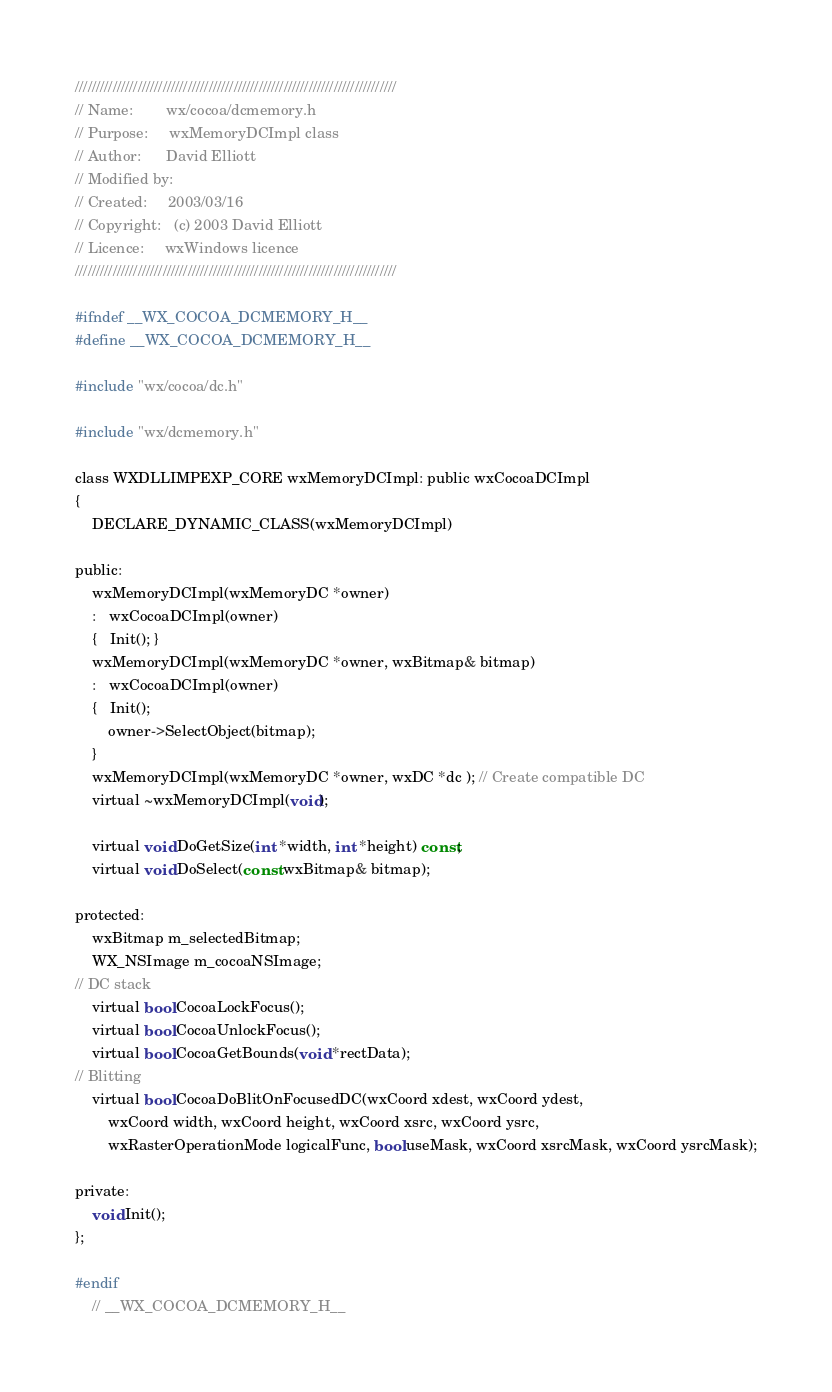Convert code to text. <code><loc_0><loc_0><loc_500><loc_500><_C_>/////////////////////////////////////////////////////////////////////////////
// Name:        wx/cocoa/dcmemory.h
// Purpose:     wxMemoryDCImpl class
// Author:      David Elliott
// Modified by:
// Created:     2003/03/16
// Copyright:   (c) 2003 David Elliott
// Licence:     wxWindows licence
/////////////////////////////////////////////////////////////////////////////

#ifndef __WX_COCOA_DCMEMORY_H__
#define __WX_COCOA_DCMEMORY_H__

#include "wx/cocoa/dc.h"

#include "wx/dcmemory.h"

class WXDLLIMPEXP_CORE wxMemoryDCImpl: public wxCocoaDCImpl
{
    DECLARE_DYNAMIC_CLASS(wxMemoryDCImpl)

public:
    wxMemoryDCImpl(wxMemoryDC *owner)
    :   wxCocoaDCImpl(owner)
    {   Init(); }
    wxMemoryDCImpl(wxMemoryDC *owner, wxBitmap& bitmap)
    :   wxCocoaDCImpl(owner)
    {   Init();
        owner->SelectObject(bitmap);
    }
    wxMemoryDCImpl(wxMemoryDC *owner, wxDC *dc ); // Create compatible DC
    virtual ~wxMemoryDCImpl(void);

    virtual void DoGetSize(int *width, int *height) const;
    virtual void DoSelect(const wxBitmap& bitmap);

protected:
    wxBitmap m_selectedBitmap;
    WX_NSImage m_cocoaNSImage;
// DC stack
    virtual bool CocoaLockFocus();
    virtual bool CocoaUnlockFocus();
    virtual bool CocoaGetBounds(void *rectData);
// Blitting
    virtual bool CocoaDoBlitOnFocusedDC(wxCoord xdest, wxCoord ydest,
        wxCoord width, wxCoord height, wxCoord xsrc, wxCoord ysrc,
        wxRasterOperationMode logicalFunc, bool useMask, wxCoord xsrcMask, wxCoord ysrcMask);

private:
    void Init();
};

#endif
    // __WX_COCOA_DCMEMORY_H__
</code> 